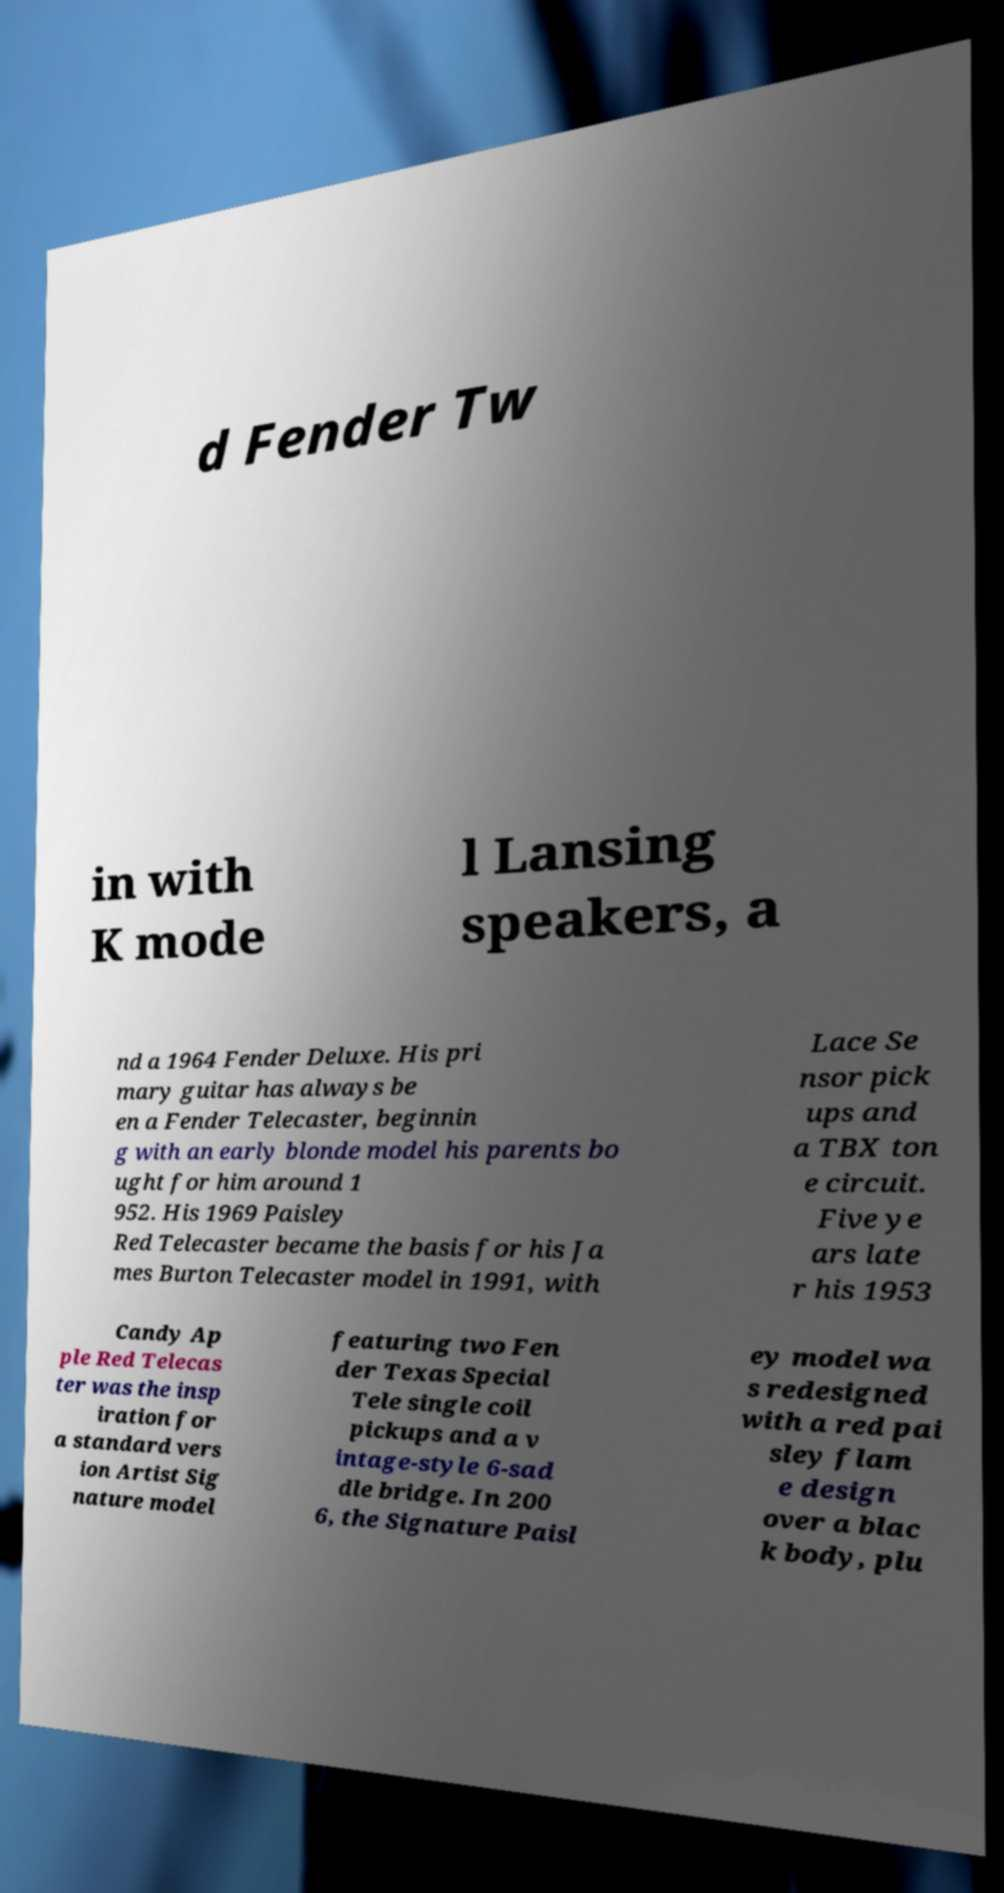Can you read and provide the text displayed in the image?This photo seems to have some interesting text. Can you extract and type it out for me? d Fender Tw in with K mode l Lansing speakers, a nd a 1964 Fender Deluxe. His pri mary guitar has always be en a Fender Telecaster, beginnin g with an early blonde model his parents bo ught for him around 1 952. His 1969 Paisley Red Telecaster became the basis for his Ja mes Burton Telecaster model in 1991, with Lace Se nsor pick ups and a TBX ton e circuit. Five ye ars late r his 1953 Candy Ap ple Red Telecas ter was the insp iration for a standard vers ion Artist Sig nature model featuring two Fen der Texas Special Tele single coil pickups and a v intage-style 6-sad dle bridge. In 200 6, the Signature Paisl ey model wa s redesigned with a red pai sley flam e design over a blac k body, plu 